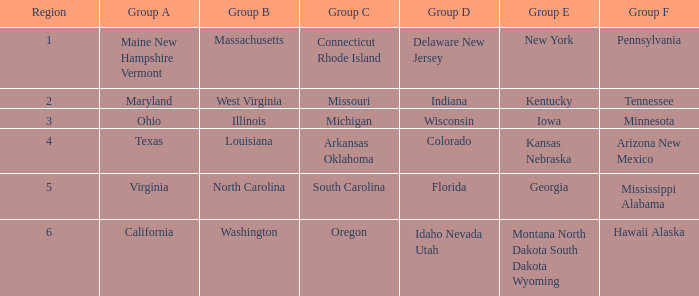What is the group C region with Illinois as group B? Michigan. 